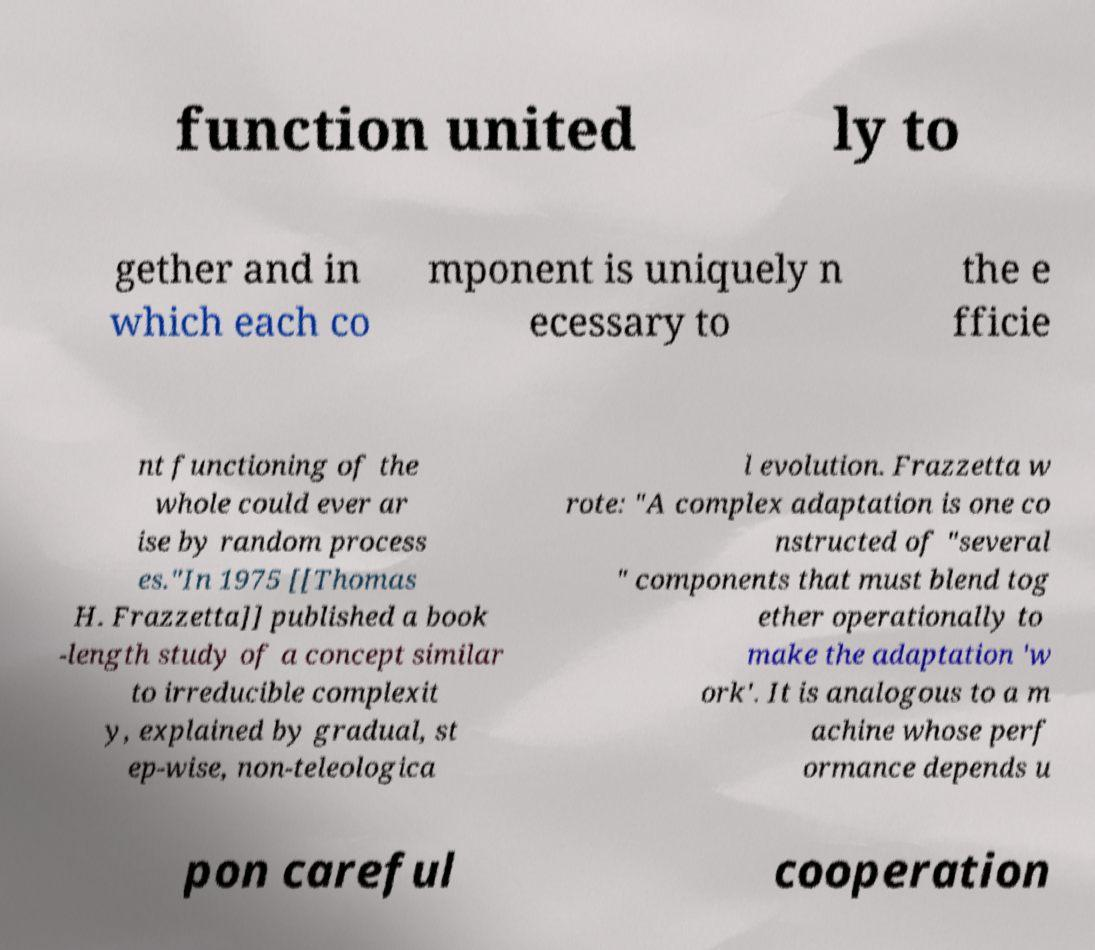Could you extract and type out the text from this image? function united ly to gether and in which each co mponent is uniquely n ecessary to the e fficie nt functioning of the whole could ever ar ise by random process es."In 1975 [[Thomas H. Frazzetta]] published a book -length study of a concept similar to irreducible complexit y, explained by gradual, st ep-wise, non-teleologica l evolution. Frazzetta w rote: "A complex adaptation is one co nstructed of "several " components that must blend tog ether operationally to make the adaptation 'w ork'. It is analogous to a m achine whose perf ormance depends u pon careful cooperation 